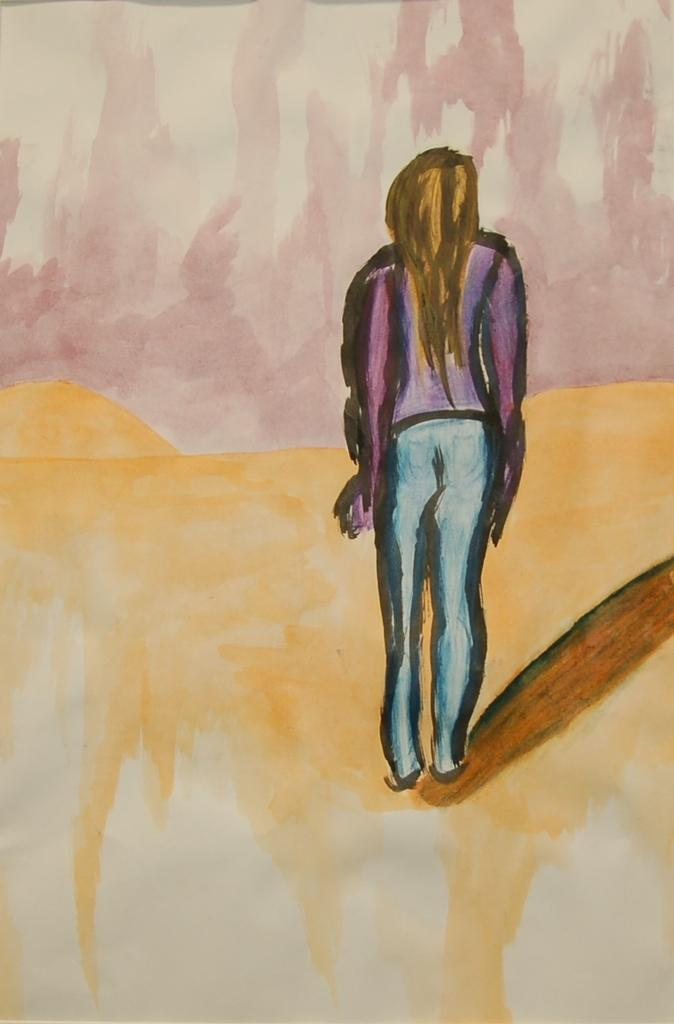What is the main subject of the image? There is a painting in the image. What is depicted in the painting? The painting contains an image of a person. How many scarecrows can be seen in the painting? There are no scarecrows present in the painting; it features an image of a person. What type of committee is responsible for the painting in the image? There is no committee mentioned or depicted in the image; it is a painting of a person. 